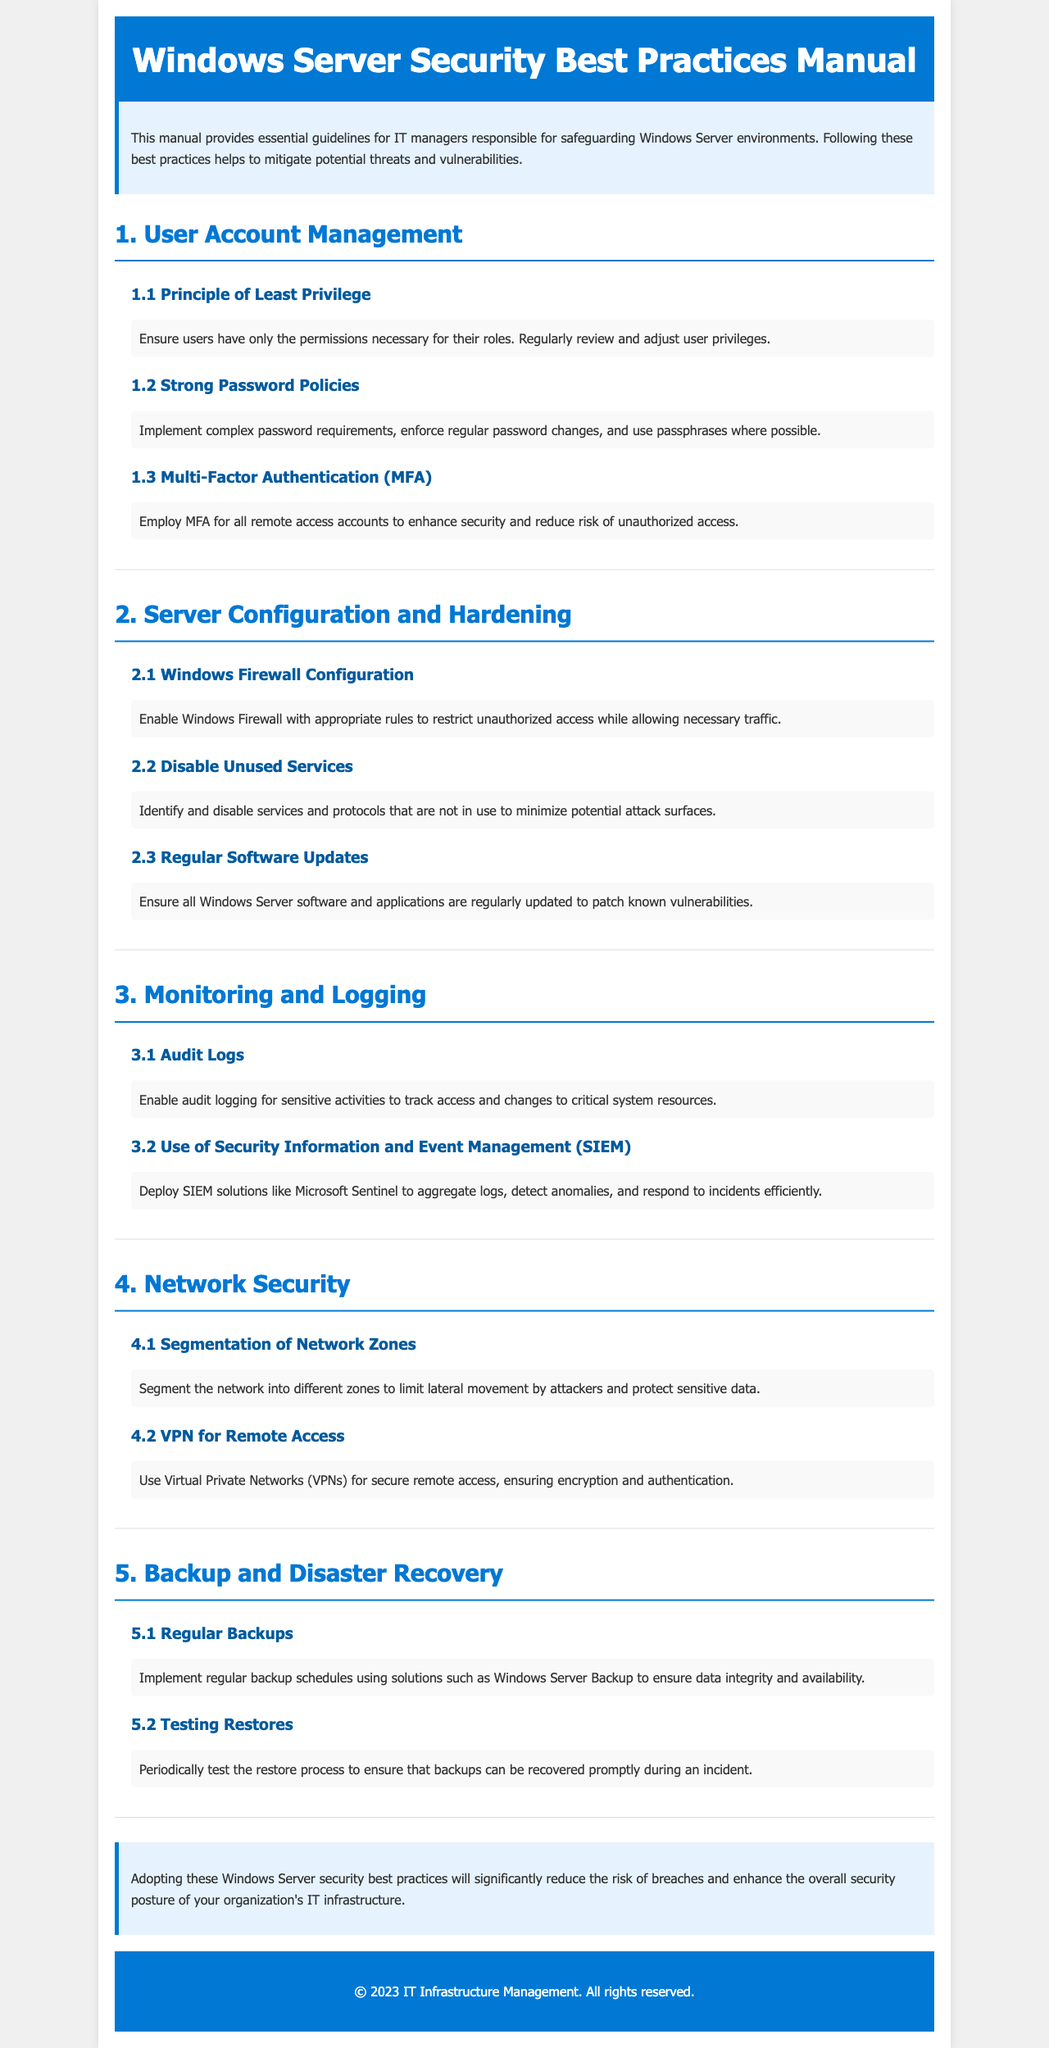What is the title of the manual? The title is found in the header of the document, which indicates the focus of the content.
Answer: Windows Server Security Best Practices Manual How many main sections are in the manual? The manual consists of several clearly defined sections, and counting the main titles gives the total number of sections.
Answer: 5 What is the first principle mentioned under User Account Management? The first principle is a core security guideline that emphasizes how user permissions should be handled.
Answer: Principle of Least Privilege What is recommended for all remote access accounts? This recommendation is aimed at enhancing security for accounts that access the server from outside the internal network.
Answer: Multi-Factor Authentication (MFA) Which solution is suggested for managing security logs? The manual includes a specific technology recommendation to improve security incident responses through log management.
Answer: Microsoft Sentinel What should be done with unused services? The manual offers advice on server configuration that helps in securing the server from unnecessary vulnerabilities.
Answer: Disable Unused Services How often should backup schedules be implemented? The recommendation implies a frequency to ensure data safety and recoverability.
Answer: Regularly What is suggested to ensure that backups can be recovered? This procedure underscores the necessity of verification processes for disaster recovery plans.
Answer: Testing Restores 